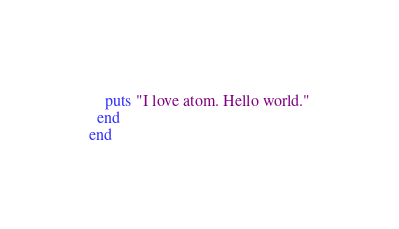Convert code to text. <code><loc_0><loc_0><loc_500><loc_500><_Ruby_>    puts "I love atom. Hello world."
  end
end
</code> 